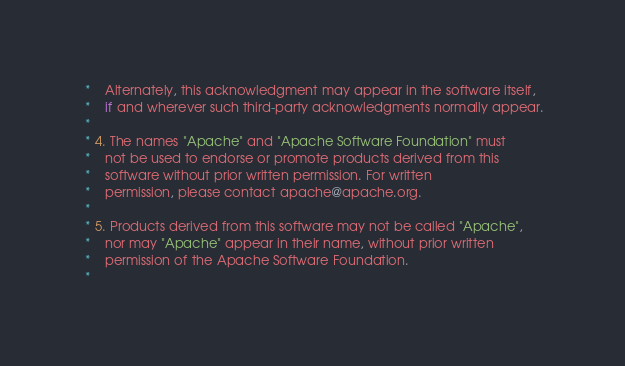<code> <loc_0><loc_0><loc_500><loc_500><_C_> *    Alternately, this acknowledgment may appear in the software itself,
 *    if and wherever such third-party acknowledgments normally appear.
 *
 * 4. The names "Apache" and "Apache Software Foundation" must
 *    not be used to endorse or promote products derived from this
 *    software without prior written permission. For written
 *    permission, please contact apache@apache.org.
 *
 * 5. Products derived from this software may not be called "Apache",
 *    nor may "Apache" appear in their name, without prior written
 *    permission of the Apache Software Foundation.
 *</code> 